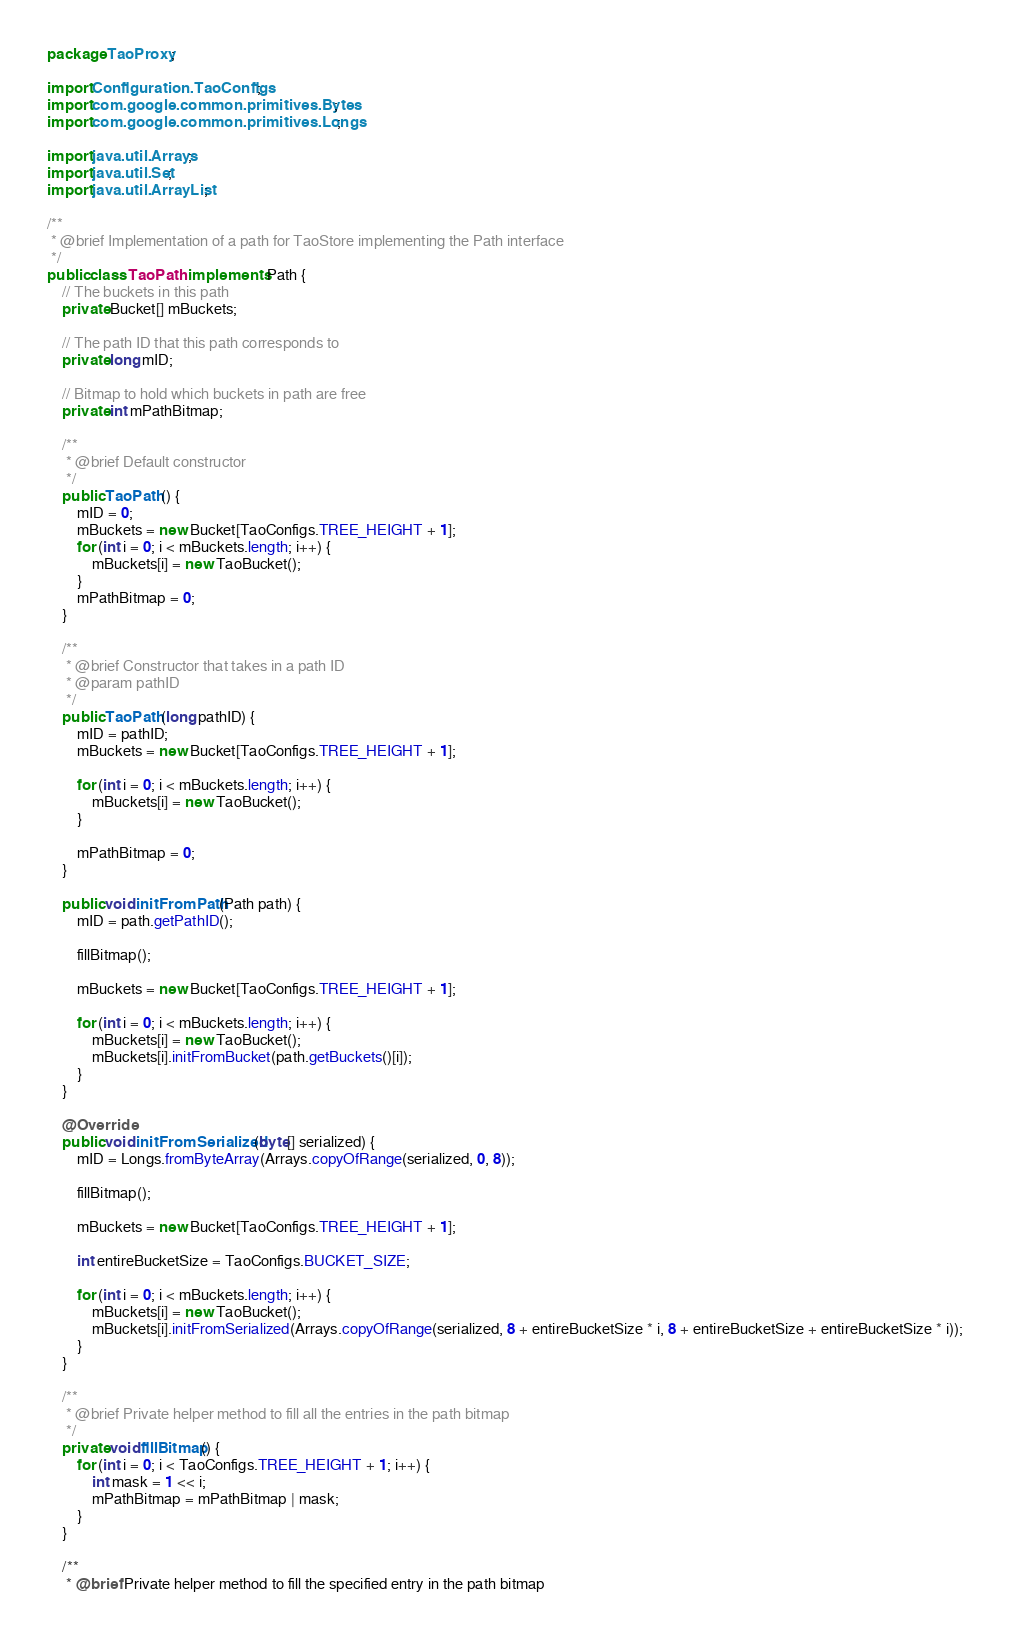<code> <loc_0><loc_0><loc_500><loc_500><_Java_>package TaoProxy;

import Configuration.TaoConfigs;
import com.google.common.primitives.Bytes;
import com.google.common.primitives.Longs;

import java.util.Arrays;
import java.util.Set;
import java.util.ArrayList;

/**
 * @brief Implementation of a path for TaoStore implementing the Path interface
 */
public class TaoPath implements Path {
    // The buckets in this path
    private Bucket[] mBuckets;

    // The path ID that this path corresponds to
    private long mID;

    // Bitmap to hold which buckets in path are free
    private int mPathBitmap;

    /**
     * @brief Default constructor
     */
    public TaoPath() {
        mID = 0;
        mBuckets = new Bucket[TaoConfigs.TREE_HEIGHT + 1];
        for (int i = 0; i < mBuckets.length; i++) {
            mBuckets[i] = new TaoBucket();
        }
        mPathBitmap = 0;
    }

    /**
     * @brief Constructor that takes in a path ID
     * @param pathID
     */
    public TaoPath(long pathID) {
        mID = pathID;
        mBuckets = new Bucket[TaoConfigs.TREE_HEIGHT + 1];

        for (int i = 0; i < mBuckets.length; i++) {
            mBuckets[i] = new TaoBucket();
        }

        mPathBitmap = 0;
    }

    public void initFromPath(Path path) {
        mID = path.getPathID();

        fillBitmap();

        mBuckets = new Bucket[TaoConfigs.TREE_HEIGHT + 1];

        for (int i = 0; i < mBuckets.length; i++) {
            mBuckets[i] = new TaoBucket();
            mBuckets[i].initFromBucket(path.getBuckets()[i]);
        }
    }

    @Override
    public void initFromSerialized(byte[] serialized) {
        mID = Longs.fromByteArray(Arrays.copyOfRange(serialized, 0, 8));

        fillBitmap();

        mBuckets = new Bucket[TaoConfigs.TREE_HEIGHT + 1];

        int entireBucketSize = TaoConfigs.BUCKET_SIZE;

        for (int i = 0; i < mBuckets.length; i++) {
            mBuckets[i] = new TaoBucket();
            mBuckets[i].initFromSerialized(Arrays.copyOfRange(serialized, 8 + entireBucketSize * i, 8 + entireBucketSize + entireBucketSize * i));
        }
    }

    /**
     * @brief Private helper method to fill all the entries in the path bitmap
     */
    private void fillBitmap() {
        for (int i = 0; i < TaoConfigs.TREE_HEIGHT + 1; i++) {
            int mask = 1 << i;
            mPathBitmap = mPathBitmap | mask;
        }
    }

    /**
     * @brief Private helper method to fill the specified entry in the path bitmap</code> 